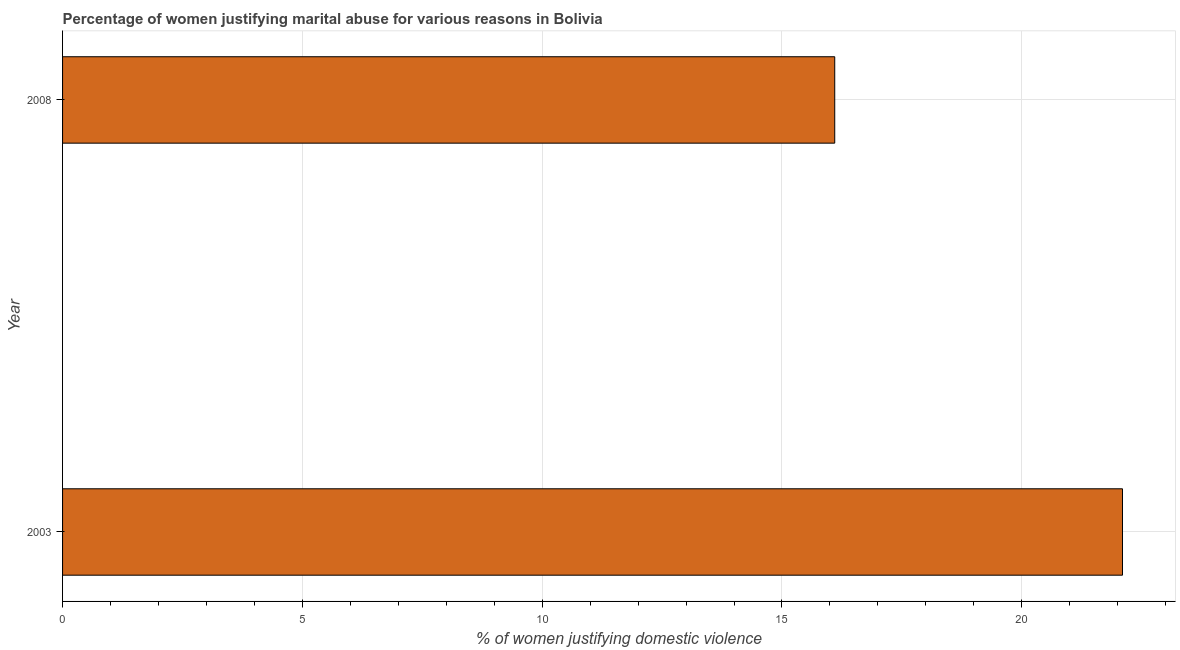What is the title of the graph?
Provide a short and direct response. Percentage of women justifying marital abuse for various reasons in Bolivia. What is the label or title of the X-axis?
Make the answer very short. % of women justifying domestic violence. What is the label or title of the Y-axis?
Offer a terse response. Year. What is the percentage of women justifying marital abuse in 2003?
Your answer should be very brief. 22.1. Across all years, what is the maximum percentage of women justifying marital abuse?
Offer a very short reply. 22.1. Across all years, what is the minimum percentage of women justifying marital abuse?
Provide a short and direct response. 16.1. In which year was the percentage of women justifying marital abuse maximum?
Make the answer very short. 2003. What is the sum of the percentage of women justifying marital abuse?
Offer a very short reply. 38.2. What is the difference between the percentage of women justifying marital abuse in 2003 and 2008?
Your response must be concise. 6. What is the average percentage of women justifying marital abuse per year?
Keep it short and to the point. 19.1. What is the median percentage of women justifying marital abuse?
Offer a terse response. 19.1. Do a majority of the years between 2003 and 2008 (inclusive) have percentage of women justifying marital abuse greater than 7 %?
Offer a very short reply. Yes. What is the ratio of the percentage of women justifying marital abuse in 2003 to that in 2008?
Provide a short and direct response. 1.37. Is the percentage of women justifying marital abuse in 2003 less than that in 2008?
Provide a succinct answer. No. Are all the bars in the graph horizontal?
Ensure brevity in your answer.  Yes. What is the difference between two consecutive major ticks on the X-axis?
Your response must be concise. 5. What is the % of women justifying domestic violence in 2003?
Offer a very short reply. 22.1. What is the % of women justifying domestic violence in 2008?
Offer a very short reply. 16.1. What is the ratio of the % of women justifying domestic violence in 2003 to that in 2008?
Provide a short and direct response. 1.37. 